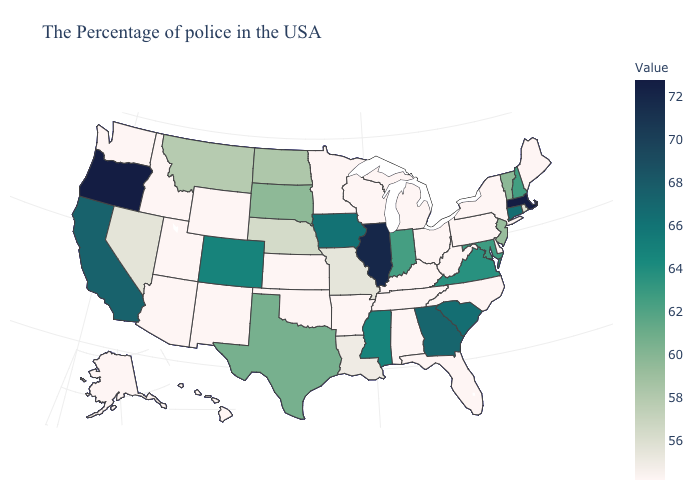Does the map have missing data?
Write a very short answer. No. Does North Dakota have the lowest value in the USA?
Be succinct. No. Does the map have missing data?
Answer briefly. No. Does the map have missing data?
Give a very brief answer. No. Which states have the highest value in the USA?
Keep it brief. Massachusetts, Oregon. 